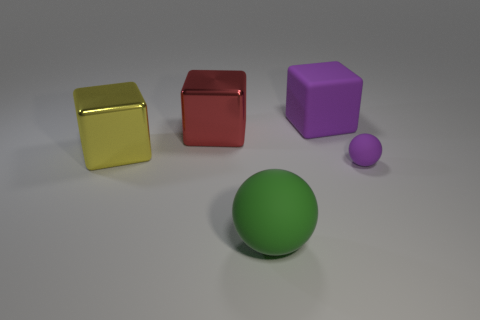There is a ball to the right of the large rubber object that is on the left side of the purple matte thing that is behind the red thing; what is its material? rubber 